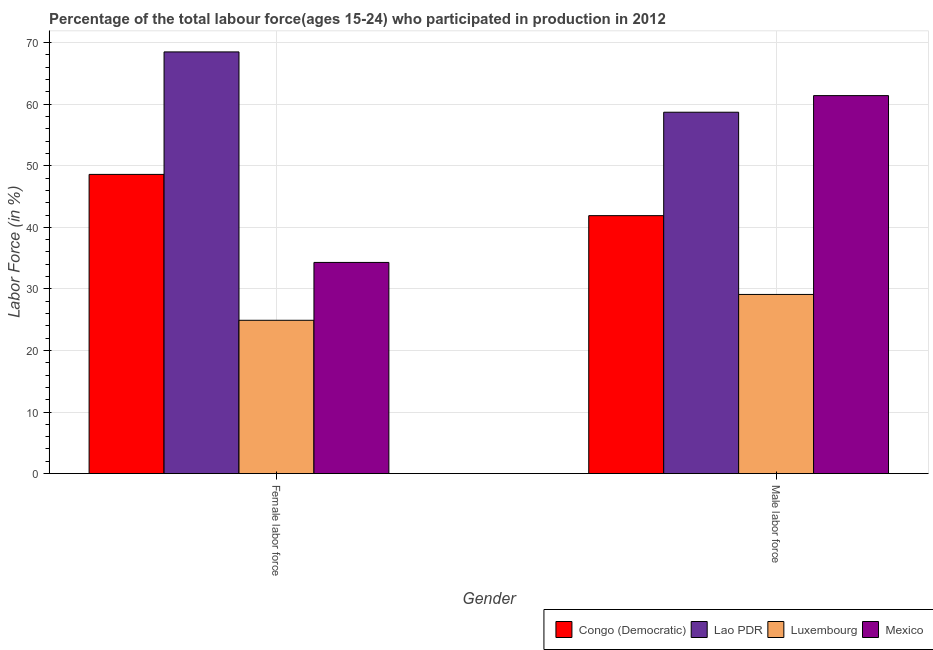How many different coloured bars are there?
Offer a terse response. 4. Are the number of bars per tick equal to the number of legend labels?
Your answer should be compact. Yes. How many bars are there on the 1st tick from the right?
Give a very brief answer. 4. What is the label of the 2nd group of bars from the left?
Ensure brevity in your answer.  Male labor force. What is the percentage of male labour force in Congo (Democratic)?
Make the answer very short. 41.9. Across all countries, what is the maximum percentage of female labor force?
Your response must be concise. 68.5. Across all countries, what is the minimum percentage of male labour force?
Keep it short and to the point. 29.1. In which country was the percentage of male labour force minimum?
Provide a short and direct response. Luxembourg. What is the total percentage of female labor force in the graph?
Offer a terse response. 176.3. What is the difference between the percentage of male labour force in Congo (Democratic) and that in Mexico?
Offer a very short reply. -19.5. What is the difference between the percentage of female labor force in Mexico and the percentage of male labour force in Lao PDR?
Your answer should be very brief. -24.4. What is the average percentage of female labor force per country?
Your response must be concise. 44.07. What is the difference between the percentage of female labor force and percentage of male labour force in Mexico?
Make the answer very short. -27.1. What is the ratio of the percentage of female labor force in Lao PDR to that in Congo (Democratic)?
Your answer should be compact. 1.41. Is the percentage of female labor force in Luxembourg less than that in Mexico?
Give a very brief answer. Yes. In how many countries, is the percentage of male labour force greater than the average percentage of male labour force taken over all countries?
Provide a short and direct response. 2. What does the 1st bar from the left in Male labor force represents?
Offer a terse response. Congo (Democratic). What does the 4th bar from the right in Male labor force represents?
Offer a very short reply. Congo (Democratic). How many bars are there?
Your response must be concise. 8. Are all the bars in the graph horizontal?
Ensure brevity in your answer.  No. How many countries are there in the graph?
Provide a short and direct response. 4. What is the difference between two consecutive major ticks on the Y-axis?
Offer a terse response. 10. Are the values on the major ticks of Y-axis written in scientific E-notation?
Your response must be concise. No. Where does the legend appear in the graph?
Keep it short and to the point. Bottom right. How many legend labels are there?
Provide a short and direct response. 4. How are the legend labels stacked?
Your answer should be compact. Horizontal. What is the title of the graph?
Keep it short and to the point. Percentage of the total labour force(ages 15-24) who participated in production in 2012. Does "Bahrain" appear as one of the legend labels in the graph?
Provide a short and direct response. No. What is the label or title of the Y-axis?
Offer a very short reply. Labor Force (in %). What is the Labor Force (in %) of Congo (Democratic) in Female labor force?
Ensure brevity in your answer.  48.6. What is the Labor Force (in %) of Lao PDR in Female labor force?
Your response must be concise. 68.5. What is the Labor Force (in %) in Luxembourg in Female labor force?
Make the answer very short. 24.9. What is the Labor Force (in %) in Mexico in Female labor force?
Your answer should be very brief. 34.3. What is the Labor Force (in %) of Congo (Democratic) in Male labor force?
Make the answer very short. 41.9. What is the Labor Force (in %) of Lao PDR in Male labor force?
Give a very brief answer. 58.7. What is the Labor Force (in %) of Luxembourg in Male labor force?
Keep it short and to the point. 29.1. What is the Labor Force (in %) in Mexico in Male labor force?
Give a very brief answer. 61.4. Across all Gender, what is the maximum Labor Force (in %) in Congo (Democratic)?
Ensure brevity in your answer.  48.6. Across all Gender, what is the maximum Labor Force (in %) of Lao PDR?
Your response must be concise. 68.5. Across all Gender, what is the maximum Labor Force (in %) in Luxembourg?
Offer a very short reply. 29.1. Across all Gender, what is the maximum Labor Force (in %) of Mexico?
Provide a succinct answer. 61.4. Across all Gender, what is the minimum Labor Force (in %) in Congo (Democratic)?
Your answer should be very brief. 41.9. Across all Gender, what is the minimum Labor Force (in %) of Lao PDR?
Your response must be concise. 58.7. Across all Gender, what is the minimum Labor Force (in %) of Luxembourg?
Provide a succinct answer. 24.9. Across all Gender, what is the minimum Labor Force (in %) in Mexico?
Make the answer very short. 34.3. What is the total Labor Force (in %) in Congo (Democratic) in the graph?
Your answer should be very brief. 90.5. What is the total Labor Force (in %) of Lao PDR in the graph?
Provide a succinct answer. 127.2. What is the total Labor Force (in %) of Luxembourg in the graph?
Offer a very short reply. 54. What is the total Labor Force (in %) in Mexico in the graph?
Offer a terse response. 95.7. What is the difference between the Labor Force (in %) in Congo (Democratic) in Female labor force and that in Male labor force?
Provide a succinct answer. 6.7. What is the difference between the Labor Force (in %) of Lao PDR in Female labor force and that in Male labor force?
Offer a very short reply. 9.8. What is the difference between the Labor Force (in %) in Mexico in Female labor force and that in Male labor force?
Provide a succinct answer. -27.1. What is the difference between the Labor Force (in %) in Congo (Democratic) in Female labor force and the Labor Force (in %) in Lao PDR in Male labor force?
Offer a terse response. -10.1. What is the difference between the Labor Force (in %) of Congo (Democratic) in Female labor force and the Labor Force (in %) of Mexico in Male labor force?
Offer a very short reply. -12.8. What is the difference between the Labor Force (in %) of Lao PDR in Female labor force and the Labor Force (in %) of Luxembourg in Male labor force?
Offer a terse response. 39.4. What is the difference between the Labor Force (in %) in Lao PDR in Female labor force and the Labor Force (in %) in Mexico in Male labor force?
Offer a terse response. 7.1. What is the difference between the Labor Force (in %) in Luxembourg in Female labor force and the Labor Force (in %) in Mexico in Male labor force?
Your answer should be very brief. -36.5. What is the average Labor Force (in %) in Congo (Democratic) per Gender?
Offer a very short reply. 45.25. What is the average Labor Force (in %) in Lao PDR per Gender?
Your response must be concise. 63.6. What is the average Labor Force (in %) of Luxembourg per Gender?
Make the answer very short. 27. What is the average Labor Force (in %) of Mexico per Gender?
Your answer should be compact. 47.85. What is the difference between the Labor Force (in %) in Congo (Democratic) and Labor Force (in %) in Lao PDR in Female labor force?
Your answer should be compact. -19.9. What is the difference between the Labor Force (in %) in Congo (Democratic) and Labor Force (in %) in Luxembourg in Female labor force?
Make the answer very short. 23.7. What is the difference between the Labor Force (in %) of Lao PDR and Labor Force (in %) of Luxembourg in Female labor force?
Provide a succinct answer. 43.6. What is the difference between the Labor Force (in %) in Lao PDR and Labor Force (in %) in Mexico in Female labor force?
Provide a short and direct response. 34.2. What is the difference between the Labor Force (in %) in Luxembourg and Labor Force (in %) in Mexico in Female labor force?
Your answer should be very brief. -9.4. What is the difference between the Labor Force (in %) in Congo (Democratic) and Labor Force (in %) in Lao PDR in Male labor force?
Provide a succinct answer. -16.8. What is the difference between the Labor Force (in %) in Congo (Democratic) and Labor Force (in %) in Luxembourg in Male labor force?
Keep it short and to the point. 12.8. What is the difference between the Labor Force (in %) of Congo (Democratic) and Labor Force (in %) of Mexico in Male labor force?
Your answer should be compact. -19.5. What is the difference between the Labor Force (in %) of Lao PDR and Labor Force (in %) of Luxembourg in Male labor force?
Give a very brief answer. 29.6. What is the difference between the Labor Force (in %) in Lao PDR and Labor Force (in %) in Mexico in Male labor force?
Your response must be concise. -2.7. What is the difference between the Labor Force (in %) in Luxembourg and Labor Force (in %) in Mexico in Male labor force?
Offer a terse response. -32.3. What is the ratio of the Labor Force (in %) of Congo (Democratic) in Female labor force to that in Male labor force?
Your answer should be very brief. 1.16. What is the ratio of the Labor Force (in %) in Lao PDR in Female labor force to that in Male labor force?
Your answer should be very brief. 1.17. What is the ratio of the Labor Force (in %) of Luxembourg in Female labor force to that in Male labor force?
Give a very brief answer. 0.86. What is the ratio of the Labor Force (in %) of Mexico in Female labor force to that in Male labor force?
Keep it short and to the point. 0.56. What is the difference between the highest and the second highest Labor Force (in %) of Congo (Democratic)?
Your answer should be very brief. 6.7. What is the difference between the highest and the second highest Labor Force (in %) of Lao PDR?
Your answer should be compact. 9.8. What is the difference between the highest and the second highest Labor Force (in %) of Luxembourg?
Offer a very short reply. 4.2. What is the difference between the highest and the second highest Labor Force (in %) in Mexico?
Provide a short and direct response. 27.1. What is the difference between the highest and the lowest Labor Force (in %) of Congo (Democratic)?
Your answer should be compact. 6.7. What is the difference between the highest and the lowest Labor Force (in %) of Lao PDR?
Provide a succinct answer. 9.8. What is the difference between the highest and the lowest Labor Force (in %) in Luxembourg?
Provide a short and direct response. 4.2. What is the difference between the highest and the lowest Labor Force (in %) of Mexico?
Your answer should be very brief. 27.1. 